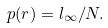<formula> <loc_0><loc_0><loc_500><loc_500>p ( r ) = l _ { \infty } / N .</formula> 